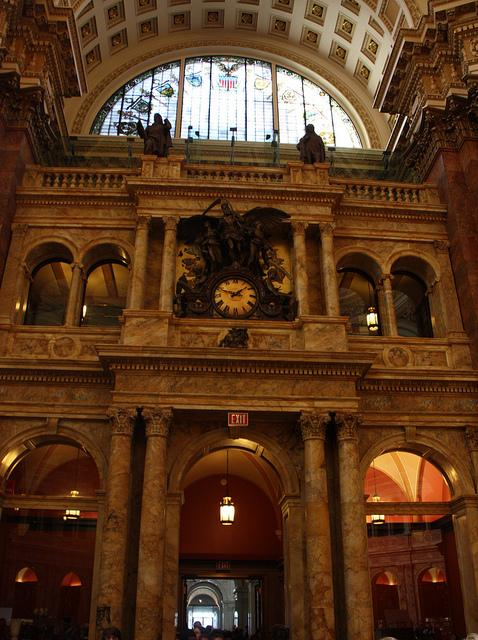What ensigns are shown at the top most part of this building? Please explain your reasoning. coatsof arms. This building is old and the design on top of the clock is an insignia of the people who previously owned the building. 